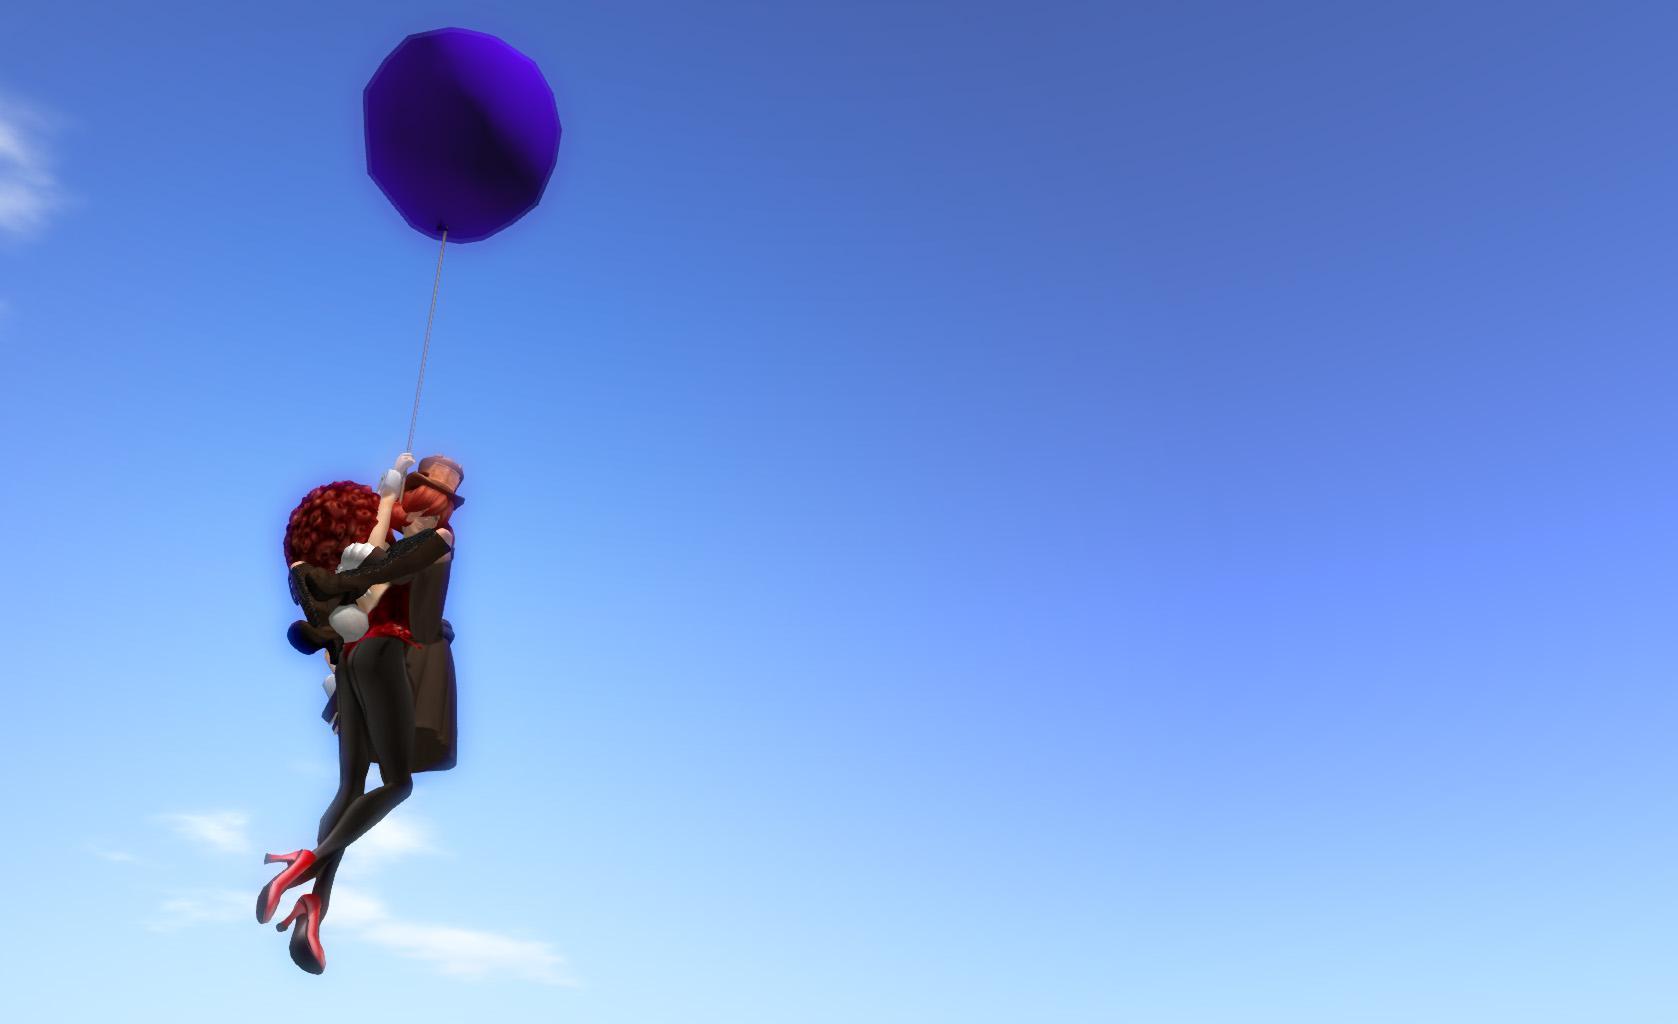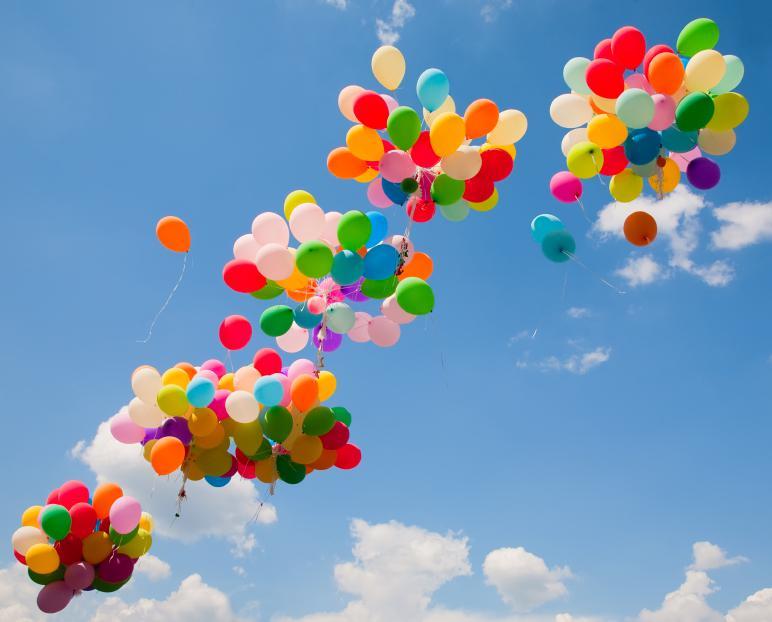The first image is the image on the left, the second image is the image on the right. For the images shown, is this caption "The left image features a string-tied 'bunch' of no more than ten balloons, and the right image shows balloons scattered across the sky." true? Answer yes or no. No. 